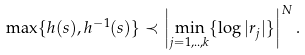<formula> <loc_0><loc_0><loc_500><loc_500>\max \{ h ( s ) , h ^ { - 1 } ( s ) \} \prec \left | \min _ { j = 1 , . . , k } \{ \log | r _ { j } | \} \right | ^ { N } .</formula> 